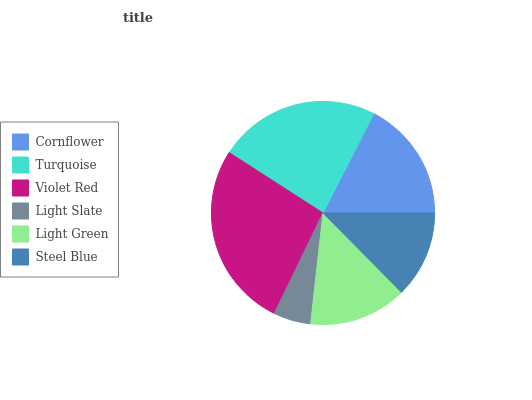Is Light Slate the minimum?
Answer yes or no. Yes. Is Violet Red the maximum?
Answer yes or no. Yes. Is Turquoise the minimum?
Answer yes or no. No. Is Turquoise the maximum?
Answer yes or no. No. Is Turquoise greater than Cornflower?
Answer yes or no. Yes. Is Cornflower less than Turquoise?
Answer yes or no. Yes. Is Cornflower greater than Turquoise?
Answer yes or no. No. Is Turquoise less than Cornflower?
Answer yes or no. No. Is Cornflower the high median?
Answer yes or no. Yes. Is Light Green the low median?
Answer yes or no. Yes. Is Steel Blue the high median?
Answer yes or no. No. Is Steel Blue the low median?
Answer yes or no. No. 